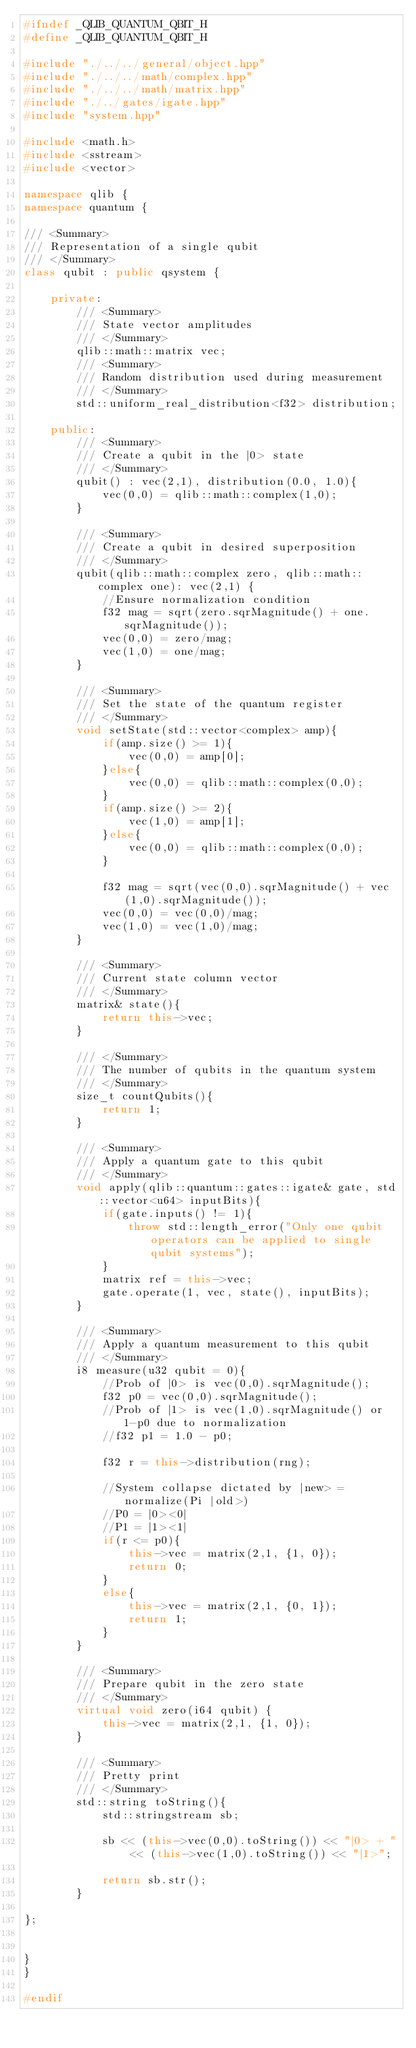<code> <loc_0><loc_0><loc_500><loc_500><_C++_>#ifndef _QLIB_QUANTUM_QBIT_H
#define _QLIB_QUANTUM_QBIT_H

#include "./../../general/object.hpp"
#include "./../../math/complex.hpp" 
#include "./../../math/matrix.hpp" 
#include "./../gates/igate.hpp"
#include "system.hpp"

#include <math.h> 
#include <sstream>
#include <vector>

namespace qlib {
namespace quantum {

/// <Summary>
/// Representation of a single qubit 
/// </Summary>
class qubit : public qsystem {

    private:
        /// <Summary>
        /// State vector amplitudes
        /// </Summary>
        qlib::math::matrix vec;
        /// <Summary>
        /// Random distribution used during measurement
        /// </Summary>
        std::uniform_real_distribution<f32> distribution;

    public:
        /// <Summary>
        /// Create a qubit in the |0> state
        /// </Summary>
        qubit() : vec(2,1), distribution(0.0, 1.0){
            vec(0,0) = qlib::math::complex(1,0);
        }

        /// <Summary>
        /// Create a qubit in desired superposition
        /// </Summary>
        qubit(qlib::math::complex zero, qlib::math::complex one): vec(2,1) {
            //Ensure normalization condition
            f32 mag = sqrt(zero.sqrMagnitude() + one.sqrMagnitude());
            vec(0,0) = zero/mag;
            vec(1,0) = one/mag;
        }

        /// <Summary>
        /// Set the state of the quantum register
        /// </Summary>
        void setState(std::vector<complex> amp){
            if(amp.size() >= 1){
                vec(0,0) = amp[0];
            }else{
                vec(0,0) = qlib::math::complex(0,0);
            }
            if(amp.size() >= 2){
                vec(1,0) = amp[1];
            }else{
                vec(0,0) = qlib::math::complex(0,0);
            }
            
            f32 mag = sqrt(vec(0,0).sqrMagnitude() + vec(1,0).sqrMagnitude());
            vec(0,0) = vec(0,0)/mag;
            vec(1,0) = vec(1,0)/mag;
        }

        /// <Summary>
        /// Current state column vector
        /// </Summary>
        matrix& state(){
            return this->vec;
        }

        /// </Summary>
        /// The number of qubits in the quantum system
        /// </Summary>
        size_t countQubits(){
            return 1;
        }

        /// <Summary>
        /// Apply a quantum gate to this qubit
        /// </Summary>
        void apply(qlib::quantum::gates::igate& gate, std::vector<u64> inputBits){
            if(gate.inputs() != 1){
                throw std::length_error("Only one qubit operators can be applied to single qubit systems"); 
            }
            matrix ref = this->vec;
            gate.operate(1, vec, state(), inputBits);
        }

        /// <Summary>
        /// Apply a quantum measurement to this qubit
        /// </Summary>
        i8 measure(u32 qubit = 0){ 
            //Prob of |0> is vec(0,0).sqrMagnitude();
            f32 p0 = vec(0,0).sqrMagnitude();
            //Prob of |1> is vec(1,0).sqrMagnitude() or 1-p0 due to normalization
            //f32 p1 = 1.0 - p0;

            f32 r = this->distribution(rng);

            //System collapse dictated by |new> = normalize(Pi |old>)
            //P0 = |0><0|
            //P1 = |1><1|
            if(r <= p0){
                this->vec = matrix(2,1, {1, 0});
                return 0;
            }
            else{
                this->vec = matrix(2,1, {0, 1});
                return 1;
            }
        }

        /// <Summary>
        /// Prepare qubit in the zero state
        /// </Summary>
        virtual void zero(i64 qubit) {
            this->vec = matrix(2,1, {1, 0});
        }

        /// <Summary>
        /// Pretty print
        /// </Summary>
        std::string toString(){
            std::stringstream sb;

            sb << (this->vec(0,0).toString()) << "|0> + " << (this->vec(1,0).toString()) << "|1>";

            return sb.str();
        }

};


}
}

#endif</code> 